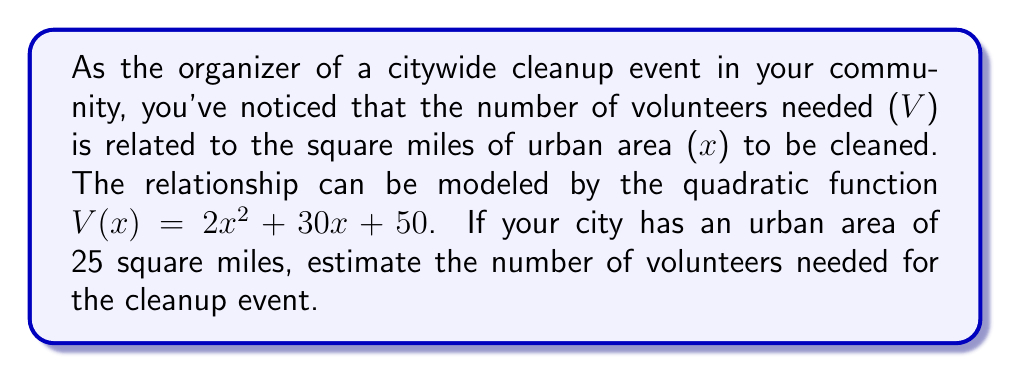Teach me how to tackle this problem. To solve this problem, we'll follow these steps:

1. Identify the given information:
   - The quadratic function: $V(x) = 2x^2 + 30x + 50$
   - The urban area to be cleaned: $x = 25$ square miles

2. Substitute $x = 25$ into the quadratic function:
   $V(25) = 2(25)^2 + 30(25) + 50$

3. Simplify the expression:
   $V(25) = 2(625) + 750 + 50$
   $V(25) = 1250 + 750 + 50$

4. Calculate the final result:
   $V(25) = 2050$

Therefore, the estimated number of volunteers needed for the citywide cleanup event is 2050.
Answer: 2050 volunteers 